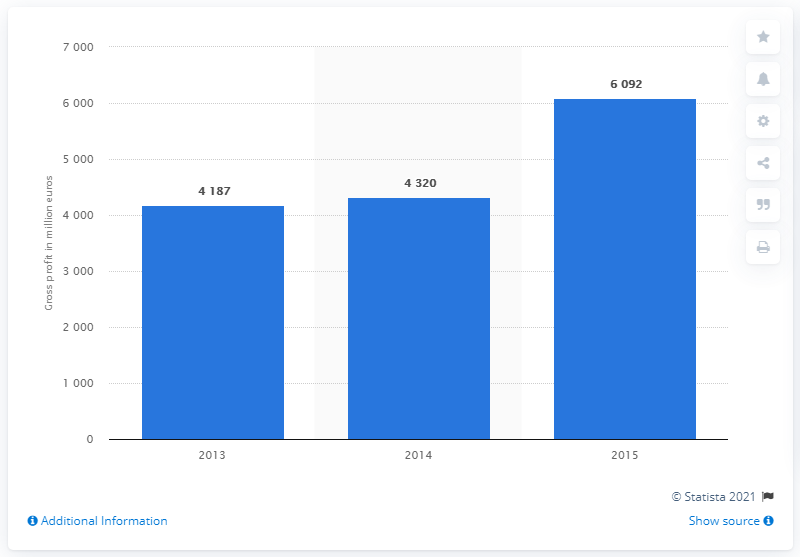Specify some key components in this picture. Porsche achieved a gross profit of approximately 4.2 billion euros in the year 2015. Porsche achieved a gross profit of approximately 4.2 billion euros in the fiscal year of 2013. In the year 2013, Porsche achieved a gross profit of approximately 4.2 billion euros. In 2013, Porsche's gross profit was 4,187. 